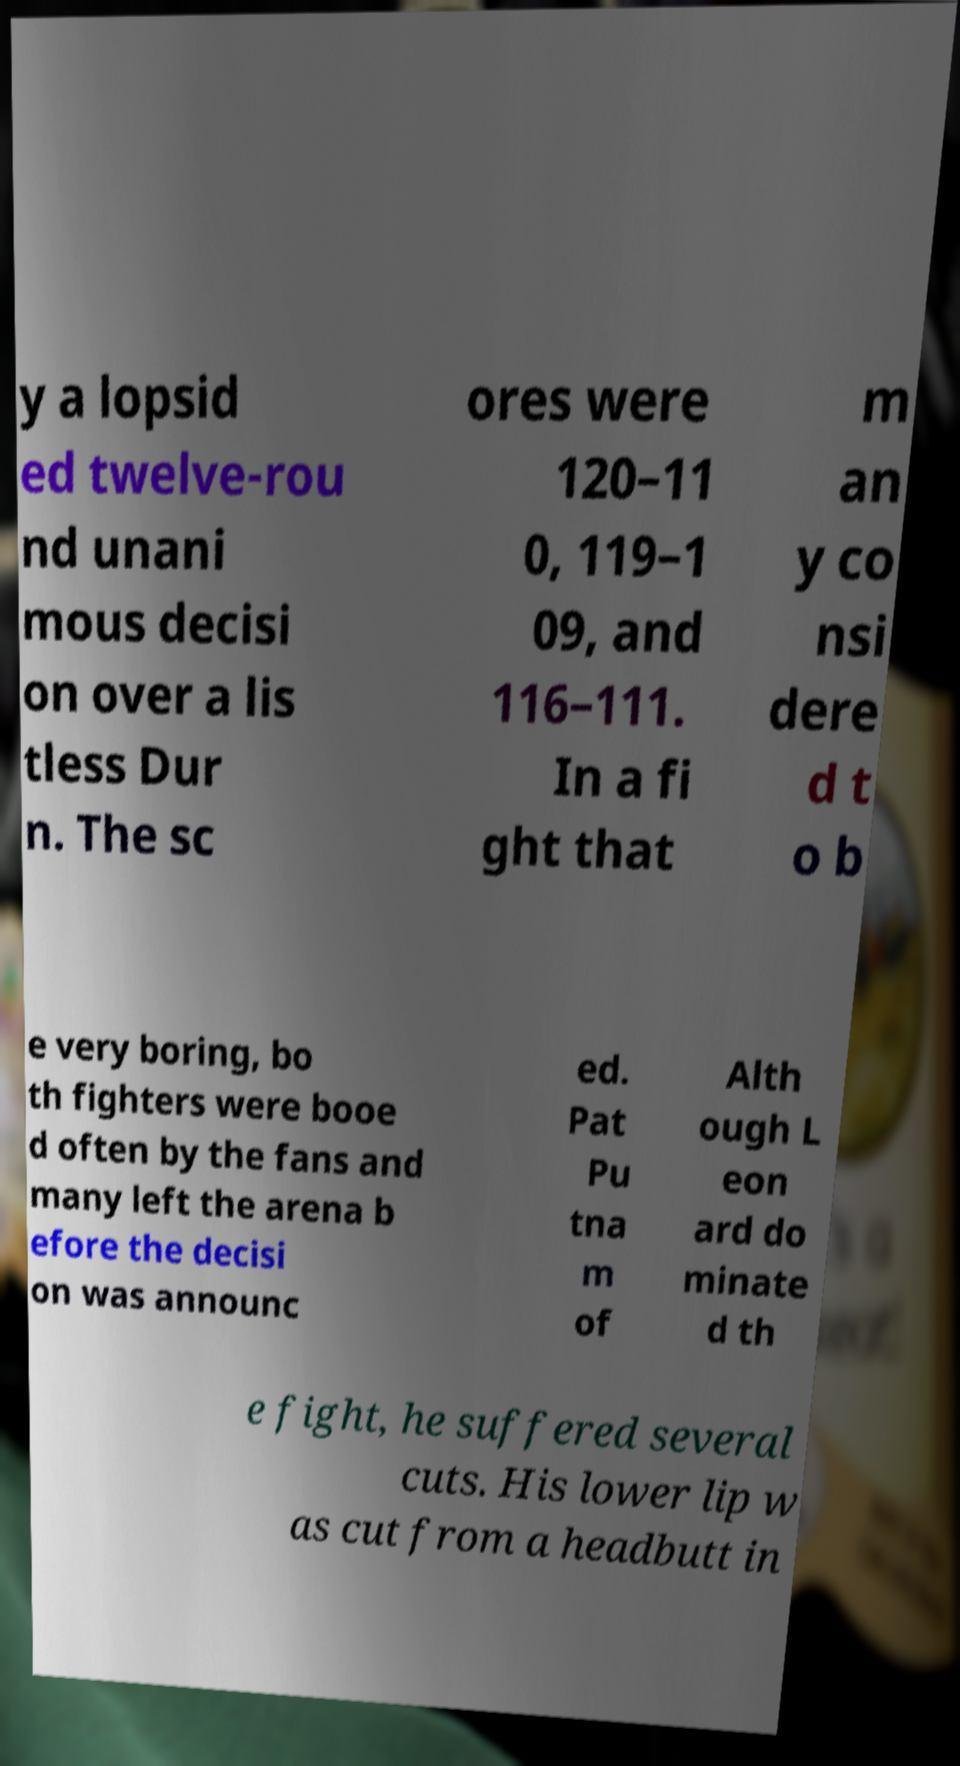For documentation purposes, I need the text within this image transcribed. Could you provide that? y a lopsid ed twelve-rou nd unani mous decisi on over a lis tless Dur n. The sc ores were 120–11 0, 119–1 09, and 116–111. In a fi ght that m an y co nsi dere d t o b e very boring, bo th fighters were booe d often by the fans and many left the arena b efore the decisi on was announc ed. Pat Pu tna m of Alth ough L eon ard do minate d th e fight, he suffered several cuts. His lower lip w as cut from a headbutt in 